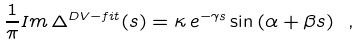Convert formula to latex. <formula><loc_0><loc_0><loc_500><loc_500>\frac { 1 } { \pi } { I m } \, \Delta ^ { D V - f i t } ( s ) = \kappa \, e ^ { - \gamma s } \sin { ( \alpha + \beta s ) } \ ,</formula> 